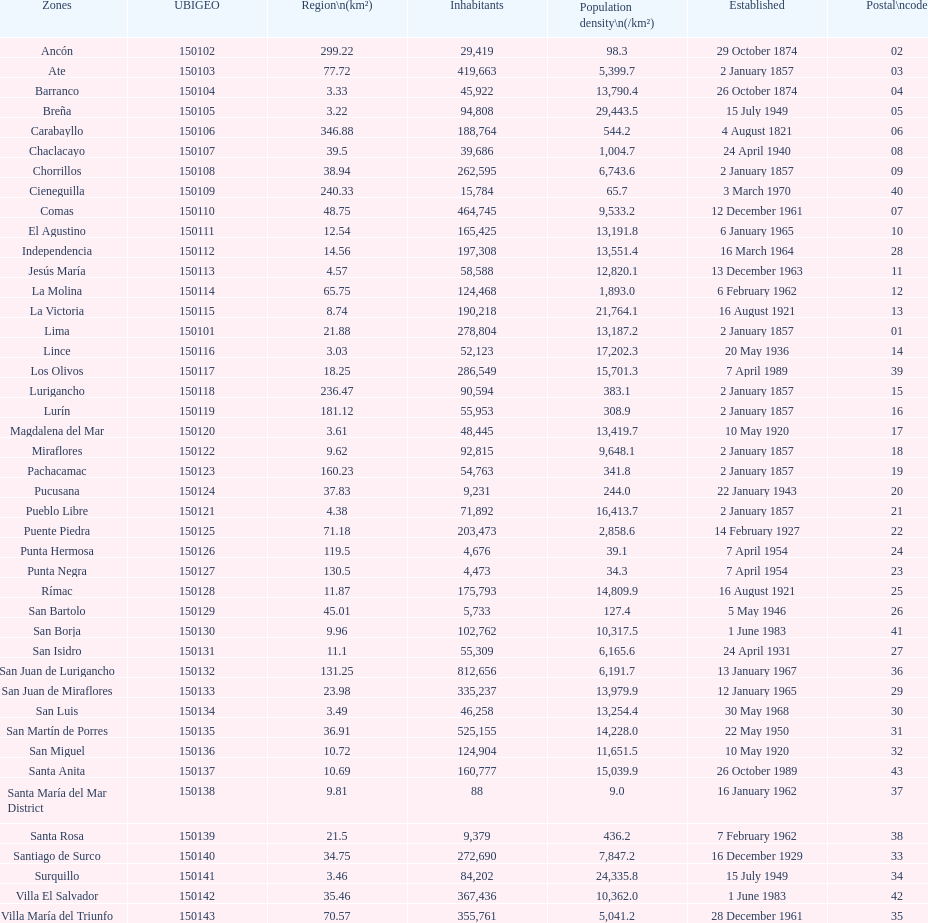Which is the largest district in terms of population? San Juan de Lurigancho. 